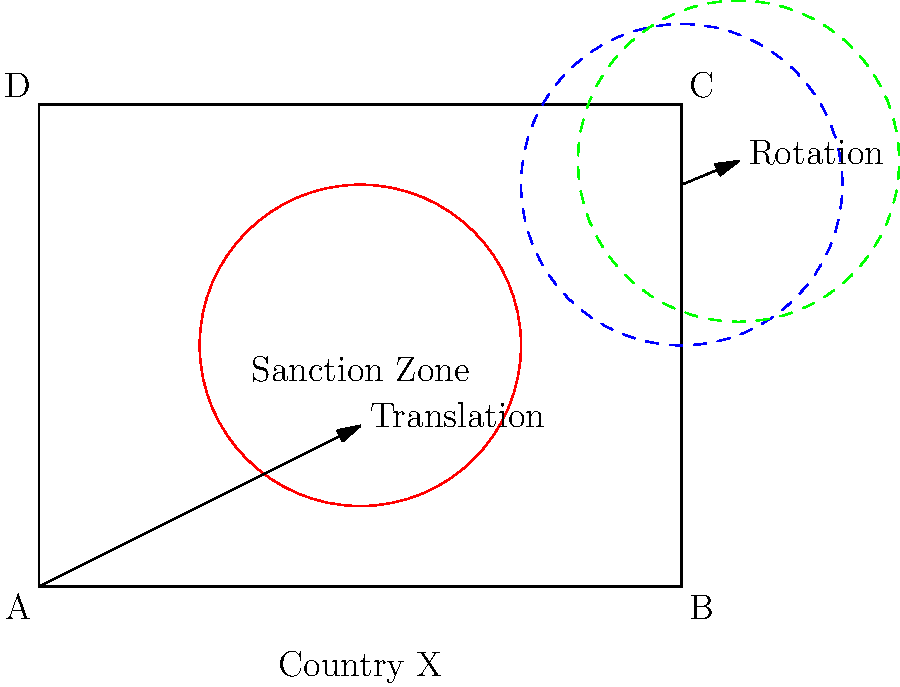Consider a geopolitical map of Country X with a circular sanction zone. The sanction zone undergoes two consecutive transformations: first, a translation of 2 units right and 1 unit up, followed by a 45-degree clockwise rotation around point C (4,3). What is the equation of the resulting transformed sanction zone circle? To solve this problem, we need to apply the transformations step-by-step:

1. Initial sanction zone:
   The original circle has its center at E(2,1.5) with a radius of 1 unit.
   Equation: $$(x-2)^2 + (y-1.5)^2 = 1^2$$

2. Translation:
   The translation moves the circle 2 units right and 1 unit up.
   New center: (2+2, 1.5+1) = (4, 2.5)
   Equation after translation: $$(x-4)^2 + (y-2.5)^2 = 1^2$$

3. Rotation:
   The 45-degree clockwise rotation around point C(4,3) can be described by the following transformation:
   $$x' = (x-4)\cos(-45°) - (y-3)\sin(-45°) + 4$$
   $$y' = (x-4)\sin(-45°) + (y-3)\cos(-45°) + 3$$

   Substituting the equation from step 2 into these formulas:
   $$((x'-4)\cos(45°) + (y'-3)\sin(45°) + 4 - 4)^2 + ((y'-3)\cos(45°) - (x'-4)\sin(45°) + 3 - 2.5)^2 = 1^2$$

4. Simplify:
   $$((x'-4)\frac{\sqrt{2}}{2} + (y'-3)\frac{\sqrt{2}}{2})^2 + ((y'-3)\frac{\sqrt{2}}{2} - (x'-4)\frac{\sqrt{2}}{2} + 0.5)^2 = 1^2$$

5. Final equation:
   $$(x'-4+y'-3)^2 + (y'-3-x'+4+1)^2 = 2$$

   Removing the primes for clarity:
   $$(x+y-7)^2 + (y-x+2)^2 = 2$$
Answer: $(x+y-7)^2 + (y-x+2)^2 = 2$ 